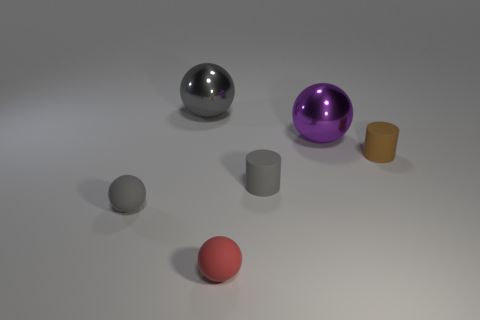Are there any metallic things?
Give a very brief answer. Yes. Is the size of the gray rubber cylinder the same as the rubber ball on the right side of the gray metal object?
Offer a terse response. Yes. There is a tiny rubber sphere that is on the right side of the small gray matte sphere; are there any small gray matte cylinders in front of it?
Offer a very short reply. No. The tiny object that is both to the right of the red rubber thing and left of the tiny brown cylinder is made of what material?
Keep it short and to the point. Rubber. The rubber thing that is on the left side of the metallic thing that is to the left of the big ball on the right side of the gray metallic ball is what color?
Keep it short and to the point. Gray. There is another ball that is the same size as the gray matte sphere; what is its color?
Ensure brevity in your answer.  Red. There is a big thing left of the tiny red rubber thing on the left side of the brown thing; what is its material?
Offer a terse response. Metal. How many matte things are right of the big purple metallic sphere and in front of the gray cylinder?
Provide a short and direct response. 0. How many other things are the same size as the purple shiny ball?
Your answer should be compact. 1. There is a gray rubber thing on the left side of the big gray metallic ball; is its shape the same as the gray object behind the small brown object?
Offer a very short reply. Yes. 